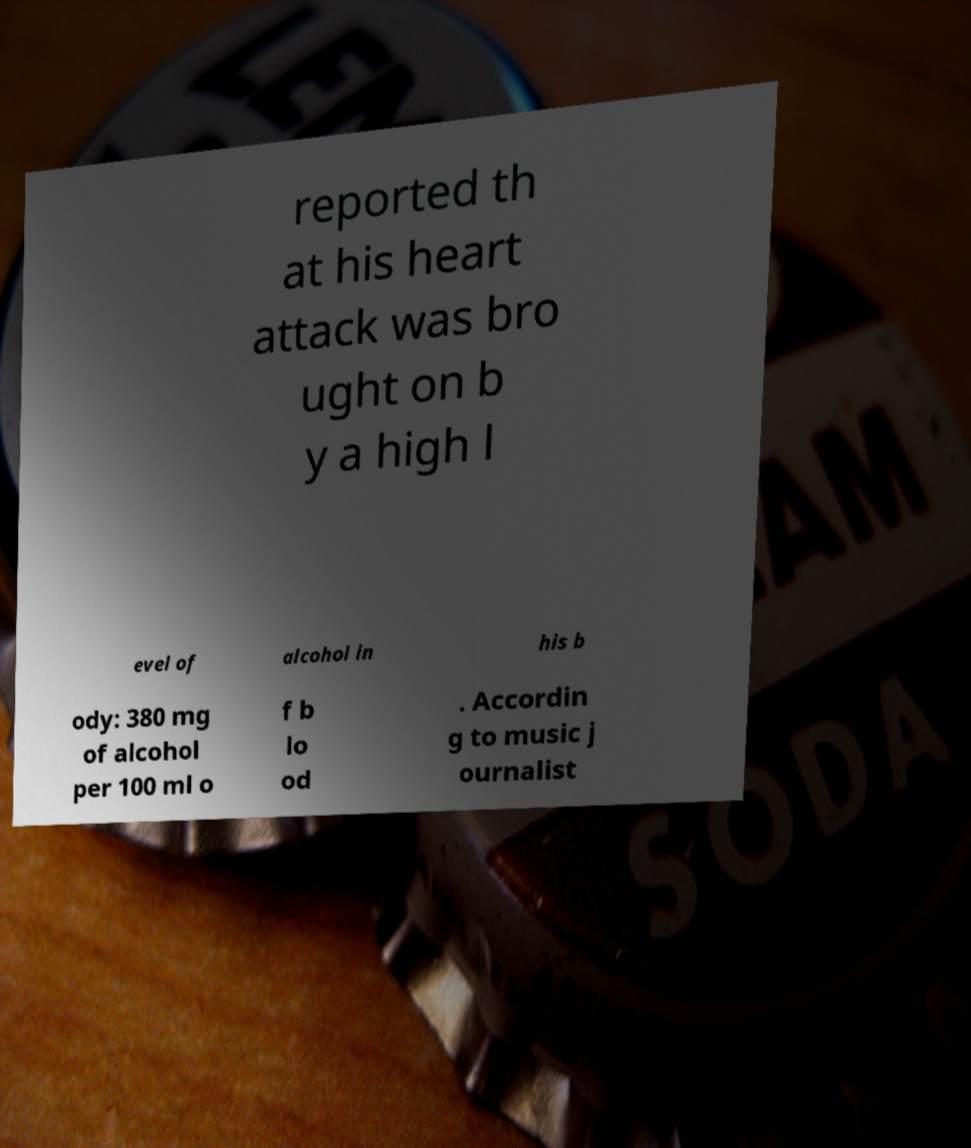Could you extract and type out the text from this image? reported th at his heart attack was bro ught on b y a high l evel of alcohol in his b ody: 380 mg of alcohol per 100 ml o f b lo od . Accordin g to music j ournalist 